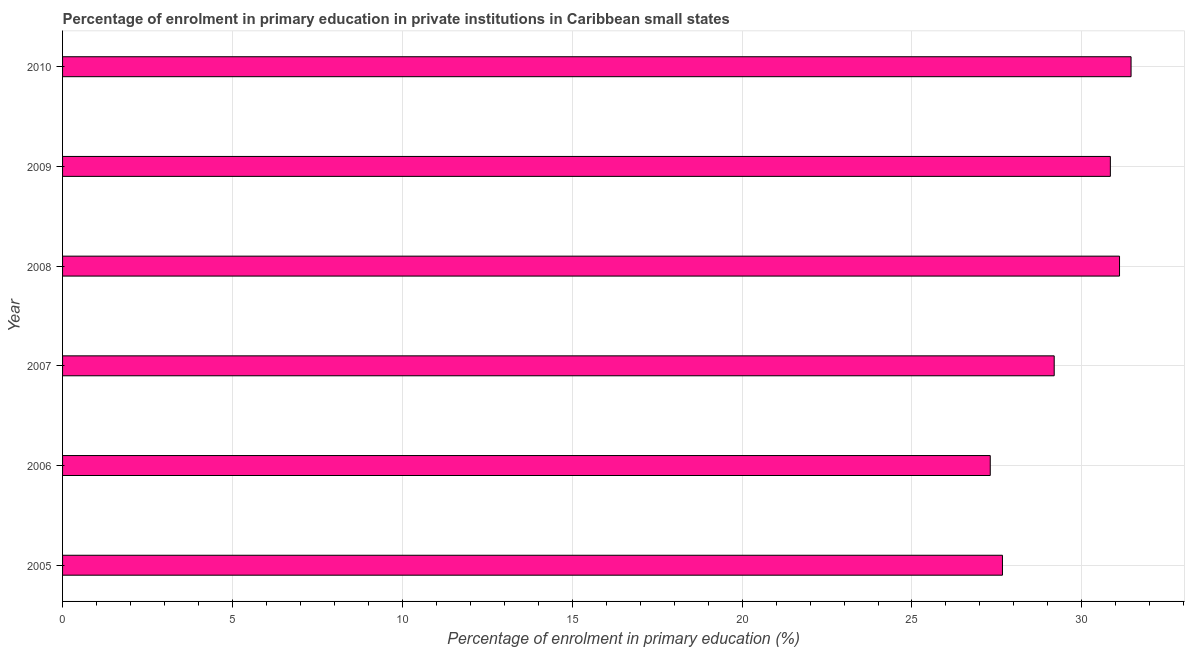Does the graph contain grids?
Give a very brief answer. Yes. What is the title of the graph?
Ensure brevity in your answer.  Percentage of enrolment in primary education in private institutions in Caribbean small states. What is the label or title of the X-axis?
Your answer should be compact. Percentage of enrolment in primary education (%). What is the enrolment percentage in primary education in 2008?
Offer a terse response. 31.11. Across all years, what is the maximum enrolment percentage in primary education?
Keep it short and to the point. 31.45. Across all years, what is the minimum enrolment percentage in primary education?
Offer a very short reply. 27.3. In which year was the enrolment percentage in primary education minimum?
Provide a short and direct response. 2006. What is the sum of the enrolment percentage in primary education?
Keep it short and to the point. 177.55. What is the difference between the enrolment percentage in primary education in 2005 and 2007?
Your answer should be very brief. -1.52. What is the average enrolment percentage in primary education per year?
Your response must be concise. 29.59. What is the median enrolment percentage in primary education?
Give a very brief answer. 30.01. In how many years, is the enrolment percentage in primary education greater than 28 %?
Offer a terse response. 4. Do a majority of the years between 2006 and 2010 (inclusive) have enrolment percentage in primary education greater than 3 %?
Your response must be concise. Yes. What is the ratio of the enrolment percentage in primary education in 2007 to that in 2008?
Provide a short and direct response. 0.94. Is the enrolment percentage in primary education in 2005 less than that in 2006?
Offer a terse response. No. What is the difference between the highest and the second highest enrolment percentage in primary education?
Make the answer very short. 0.34. Is the sum of the enrolment percentage in primary education in 2005 and 2009 greater than the maximum enrolment percentage in primary education across all years?
Give a very brief answer. Yes. What is the difference between the highest and the lowest enrolment percentage in primary education?
Ensure brevity in your answer.  4.14. Are all the bars in the graph horizontal?
Make the answer very short. Yes. Are the values on the major ticks of X-axis written in scientific E-notation?
Offer a terse response. No. What is the Percentage of enrolment in primary education (%) of 2005?
Provide a succinct answer. 27.66. What is the Percentage of enrolment in primary education (%) of 2006?
Provide a succinct answer. 27.3. What is the Percentage of enrolment in primary education (%) of 2007?
Ensure brevity in your answer.  29.19. What is the Percentage of enrolment in primary education (%) of 2008?
Provide a short and direct response. 31.11. What is the Percentage of enrolment in primary education (%) in 2009?
Your response must be concise. 30.84. What is the Percentage of enrolment in primary education (%) of 2010?
Keep it short and to the point. 31.45. What is the difference between the Percentage of enrolment in primary education (%) in 2005 and 2006?
Your response must be concise. 0.36. What is the difference between the Percentage of enrolment in primary education (%) in 2005 and 2007?
Offer a terse response. -1.52. What is the difference between the Percentage of enrolment in primary education (%) in 2005 and 2008?
Provide a short and direct response. -3.45. What is the difference between the Percentage of enrolment in primary education (%) in 2005 and 2009?
Offer a terse response. -3.18. What is the difference between the Percentage of enrolment in primary education (%) in 2005 and 2010?
Ensure brevity in your answer.  -3.79. What is the difference between the Percentage of enrolment in primary education (%) in 2006 and 2007?
Offer a very short reply. -1.88. What is the difference between the Percentage of enrolment in primary education (%) in 2006 and 2008?
Your answer should be very brief. -3.81. What is the difference between the Percentage of enrolment in primary education (%) in 2006 and 2009?
Give a very brief answer. -3.54. What is the difference between the Percentage of enrolment in primary education (%) in 2006 and 2010?
Give a very brief answer. -4.14. What is the difference between the Percentage of enrolment in primary education (%) in 2007 and 2008?
Your answer should be compact. -1.92. What is the difference between the Percentage of enrolment in primary education (%) in 2007 and 2009?
Give a very brief answer. -1.65. What is the difference between the Percentage of enrolment in primary education (%) in 2007 and 2010?
Your answer should be very brief. -2.26. What is the difference between the Percentage of enrolment in primary education (%) in 2008 and 2009?
Offer a very short reply. 0.27. What is the difference between the Percentage of enrolment in primary education (%) in 2008 and 2010?
Give a very brief answer. -0.34. What is the difference between the Percentage of enrolment in primary education (%) in 2009 and 2010?
Your response must be concise. -0.61. What is the ratio of the Percentage of enrolment in primary education (%) in 2005 to that in 2007?
Your response must be concise. 0.95. What is the ratio of the Percentage of enrolment in primary education (%) in 2005 to that in 2008?
Make the answer very short. 0.89. What is the ratio of the Percentage of enrolment in primary education (%) in 2005 to that in 2009?
Keep it short and to the point. 0.9. What is the ratio of the Percentage of enrolment in primary education (%) in 2006 to that in 2007?
Make the answer very short. 0.94. What is the ratio of the Percentage of enrolment in primary education (%) in 2006 to that in 2008?
Provide a short and direct response. 0.88. What is the ratio of the Percentage of enrolment in primary education (%) in 2006 to that in 2009?
Your answer should be very brief. 0.89. What is the ratio of the Percentage of enrolment in primary education (%) in 2006 to that in 2010?
Keep it short and to the point. 0.87. What is the ratio of the Percentage of enrolment in primary education (%) in 2007 to that in 2008?
Your answer should be compact. 0.94. What is the ratio of the Percentage of enrolment in primary education (%) in 2007 to that in 2009?
Your answer should be compact. 0.95. What is the ratio of the Percentage of enrolment in primary education (%) in 2007 to that in 2010?
Ensure brevity in your answer.  0.93. What is the ratio of the Percentage of enrolment in primary education (%) in 2008 to that in 2010?
Offer a very short reply. 0.99. 